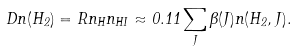Convert formula to latex. <formula><loc_0><loc_0><loc_500><loc_500>D n ( H _ { 2 } ) = R n _ { H } n _ { H I } \approx 0 . 1 1 \sum _ { J } \beta ( J ) n ( H _ { 2 } , J ) .</formula> 